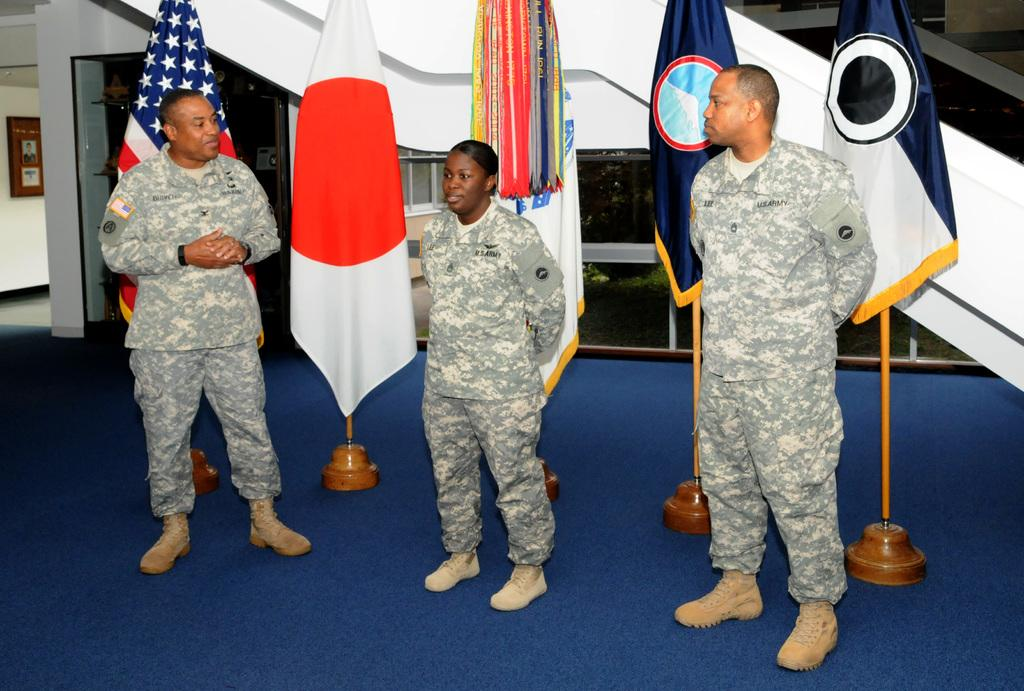How many people are in the foreground of the image? There are three people standing in the foreground of the image. What can be seen in the background of the image? There is a flag visible in the background of the image. What direction are the people laughing in the image? There is no indication in the image that the people are laughing, and therefore no direction can be determined. 